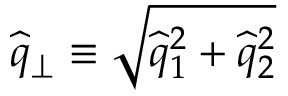Convert formula to latex. <formula><loc_0><loc_0><loc_500><loc_500>\widehat { q } _ { \perp } \equiv \sqrt { \widehat { q } _ { 1 } ^ { 2 } + \widehat { q } _ { 2 } ^ { 2 } }</formula> 